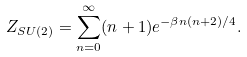Convert formula to latex. <formula><loc_0><loc_0><loc_500><loc_500>Z _ { S U ( 2 ) } = \sum _ { n = 0 } ^ { \infty } ( n + 1 ) e ^ { - \beta n ( n + 2 ) / 4 } .</formula> 